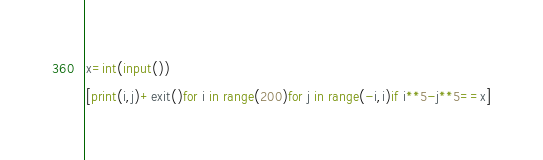Convert code to text. <code><loc_0><loc_0><loc_500><loc_500><_Python_>x=int(input())
[print(i,j)+exit()for i in range(200)for j in range(-i,i)if i**5-j**5==x]</code> 